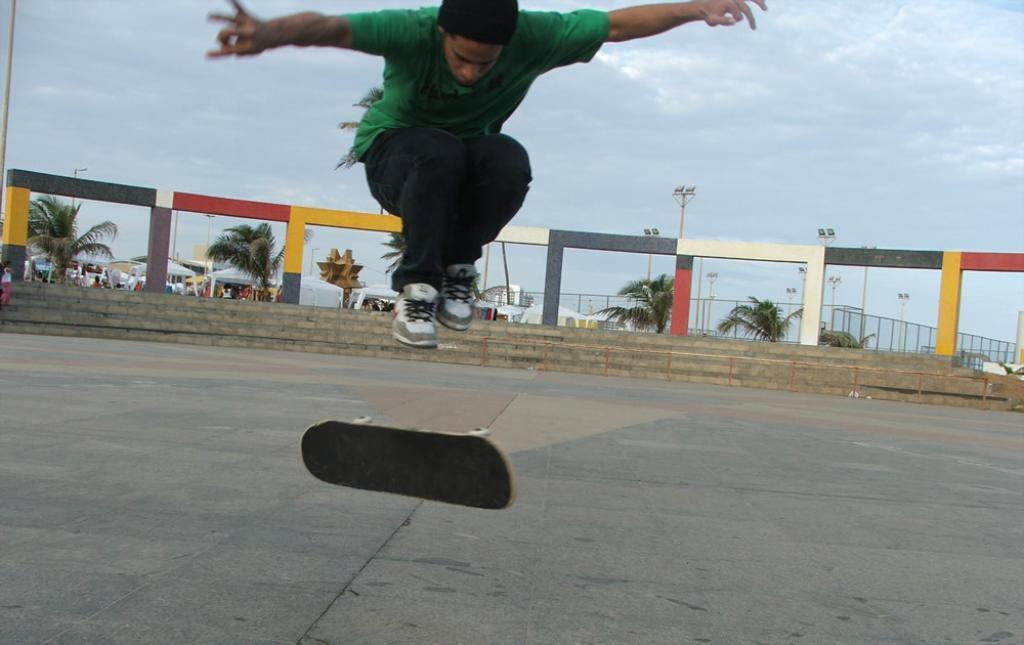What is the main subject of the image? There is a man in the image. What is the man doing in the image? The man is on a skateboard. What is the position of the skateboard in the image? The skateboard is in the air. What architectural features can be seen in the image? There are steps, poles, and a fence in the image. What type of vegetation is present in the image? There are trees in the image. What commercial features are present in the image? There are stalls in the image. What is visible in the background of the image? The sky is visible in the background, and clouds are present in the sky. What type of flock can be seen flying in the image? There is no flock of birds or animals visible in the image. What type of produce is being sold at the stalls in the image? The image does not provide information about the type of produce being sold at the stalls. 